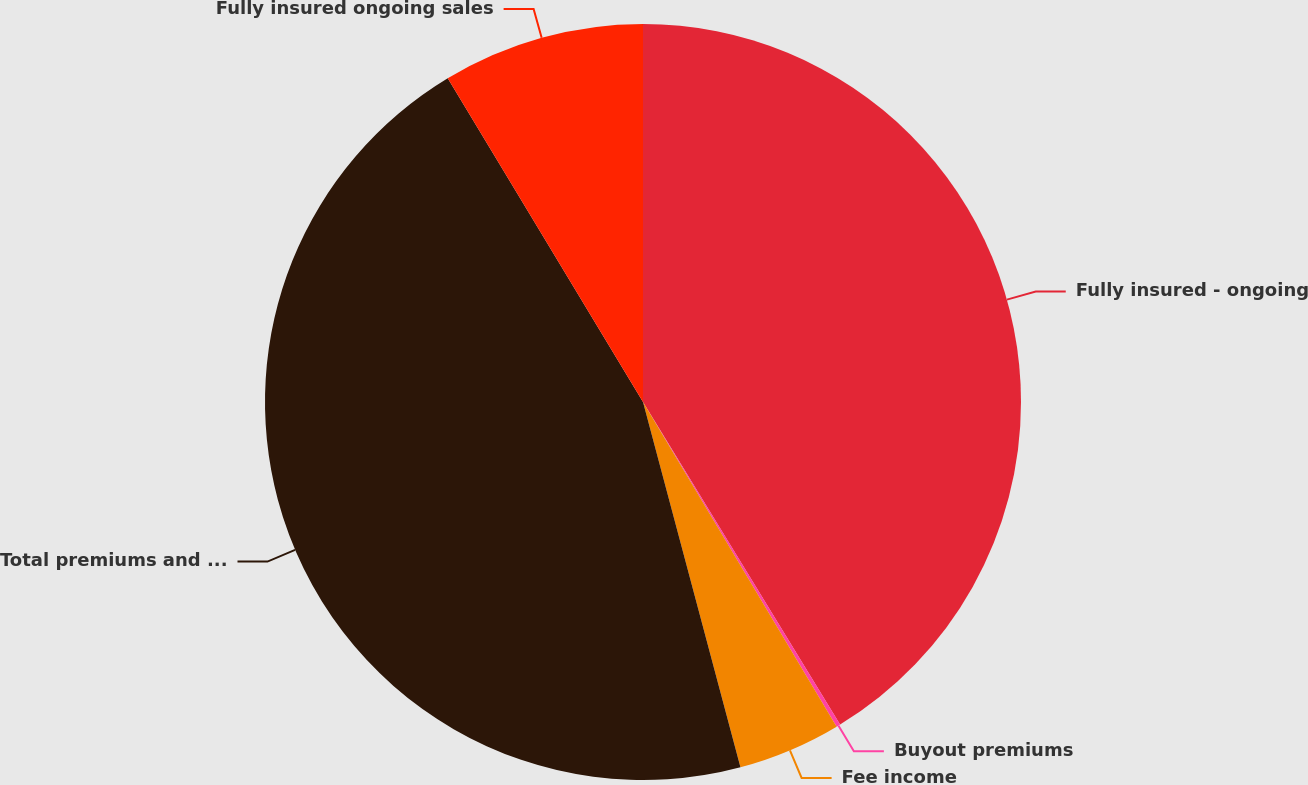<chart> <loc_0><loc_0><loc_500><loc_500><pie_chart><fcel>Fully insured - ongoing<fcel>Buyout premiums<fcel>Fee income<fcel>Total premiums and other<fcel>Fully insured ongoing sales<nl><fcel>41.27%<fcel>0.17%<fcel>4.41%<fcel>45.51%<fcel>8.64%<nl></chart> 